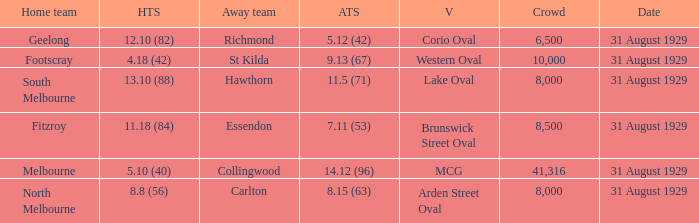What was the away team when the game was at corio oval? Richmond. Would you mind parsing the complete table? {'header': ['Home team', 'HTS', 'Away team', 'ATS', 'V', 'Crowd', 'Date'], 'rows': [['Geelong', '12.10 (82)', 'Richmond', '5.12 (42)', 'Corio Oval', '6,500', '31 August 1929'], ['Footscray', '4.18 (42)', 'St Kilda', '9.13 (67)', 'Western Oval', '10,000', '31 August 1929'], ['South Melbourne', '13.10 (88)', 'Hawthorn', '11.5 (71)', 'Lake Oval', '8,000', '31 August 1929'], ['Fitzroy', '11.18 (84)', 'Essendon', '7.11 (53)', 'Brunswick Street Oval', '8,500', '31 August 1929'], ['Melbourne', '5.10 (40)', 'Collingwood', '14.12 (96)', 'MCG', '41,316', '31 August 1929'], ['North Melbourne', '8.8 (56)', 'Carlton', '8.15 (63)', 'Arden Street Oval', '8,000', '31 August 1929']]} 